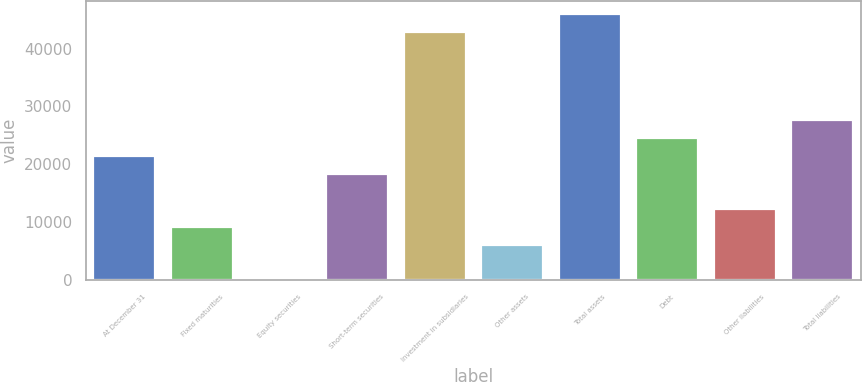Convert chart to OTSL. <chart><loc_0><loc_0><loc_500><loc_500><bar_chart><fcel>At December 31<fcel>Fixed maturities<fcel>Equity securities<fcel>Short-term securities<fcel>Investment in subsidiaries<fcel>Other assets<fcel>Total assets<fcel>Debt<fcel>Other liabilities<fcel>Total liabilities<nl><fcel>21475.9<fcel>9229.1<fcel>44<fcel>18414.2<fcel>42907.8<fcel>6167.4<fcel>45969.5<fcel>24537.6<fcel>12290.8<fcel>27599.3<nl></chart> 